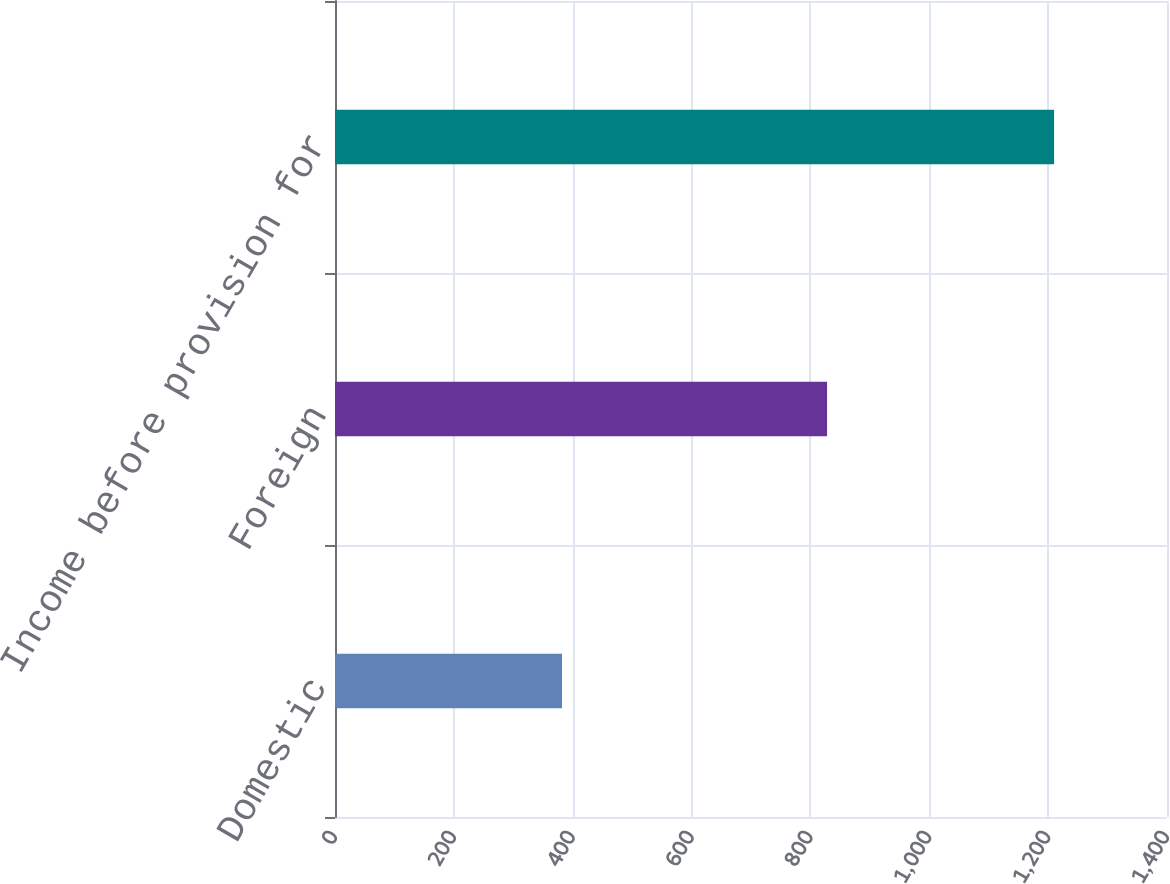<chart> <loc_0><loc_0><loc_500><loc_500><bar_chart><fcel>Domestic<fcel>Foreign<fcel>Income before provision for<nl><fcel>382<fcel>828<fcel>1210<nl></chart> 